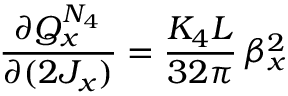<formula> <loc_0><loc_0><loc_500><loc_500>\frac { \partial Q _ { x } ^ { N _ { 4 } } } { \partial ( 2 J _ { x } ) } = \frac { K _ { 4 } L } { 3 2 \pi } \, \beta _ { x } ^ { 2 }</formula> 